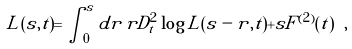<formula> <loc_0><loc_0><loc_500><loc_500>L ( s , t ) = \int ^ { s } _ { 0 } d r \, r D ^ { 2 } _ { t } \log L ( s - r , t ) + s F ^ { ( 2 ) } ( t ) \ ,</formula> 